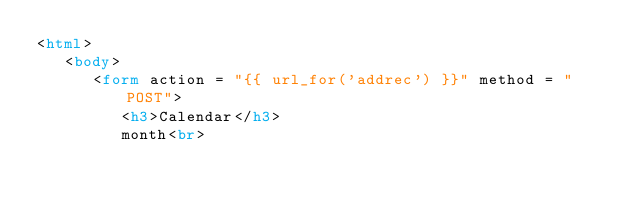<code> <loc_0><loc_0><loc_500><loc_500><_HTML_><html>
   <body>
      <form action = "{{ url_for('addrec') }}" method = "POST">
         <h3>Calendar</h3>
         month<br></code> 